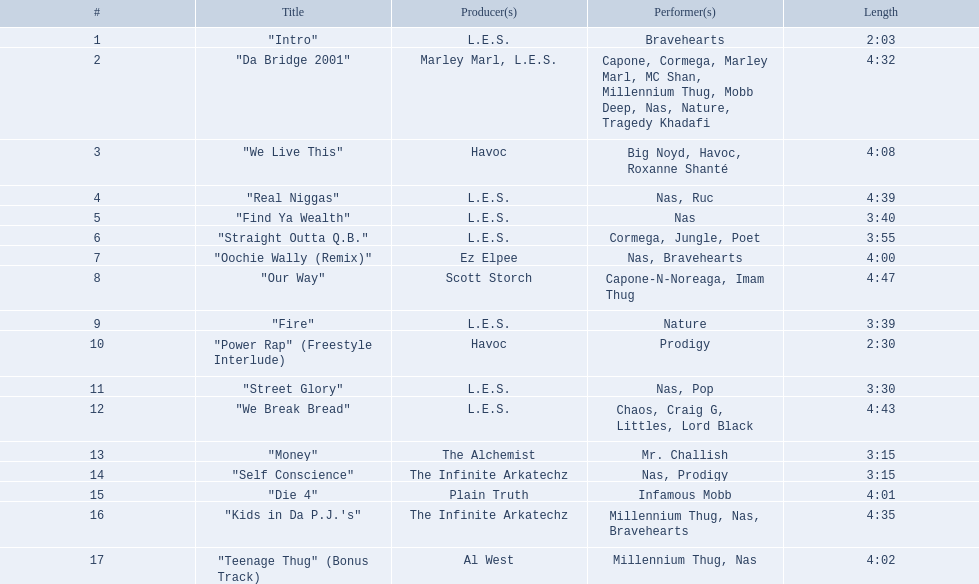What are the titles of all the songs? "Intro", "Da Bridge 2001", "We Live This", "Real Niggas", "Find Ya Wealth", "Straight Outta Q.B.", "Oochie Wally (Remix)", "Our Way", "Fire", "Power Rap" (Freestyle Interlude), "Street Glory", "We Break Bread", "Money", "Self Conscience", "Die 4", "Kids in Da P.J.'s", "Teenage Thug" (Bonus Track). Who is responsible for producing these tracks? L.E.S., Marley Marl, L.E.S., Ez Elpee, Scott Storch, Havoc, The Alchemist, The Infinite Arkatechz, Plain Truth, Al West. Among the producers, who created the briefest song? L.E.S. What is the duration of this producer's shortest track? 2:03. 